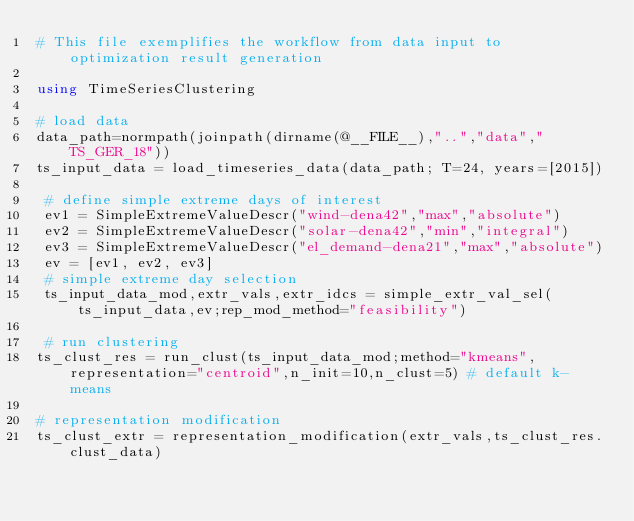Convert code to text. <code><loc_0><loc_0><loc_500><loc_500><_Julia_># This file exemplifies the workflow from data input to optimization result generation

using TimeSeriesClustering

# load data
data_path=normpath(joinpath(dirname(@__FILE__),"..","data","TS_GER_18"))
ts_input_data = load_timeseries_data(data_path; T=24, years=[2015])

 # define simple extreme days of interest
 ev1 = SimpleExtremeValueDescr("wind-dena42","max","absolute")
 ev2 = SimpleExtremeValueDescr("solar-dena42","min","integral")
 ev3 = SimpleExtremeValueDescr("el_demand-dena21","max","absolute")
 ev = [ev1, ev2, ev3]
 # simple extreme day selection
 ts_input_data_mod,extr_vals,extr_idcs = simple_extr_val_sel(ts_input_data,ev;rep_mod_method="feasibility")

 # run clustering
ts_clust_res = run_clust(ts_input_data_mod;method="kmeans",representation="centroid",n_init=10,n_clust=5) # default k-means

# representation modification
ts_clust_extr = representation_modification(extr_vals,ts_clust_res.clust_data)
</code> 